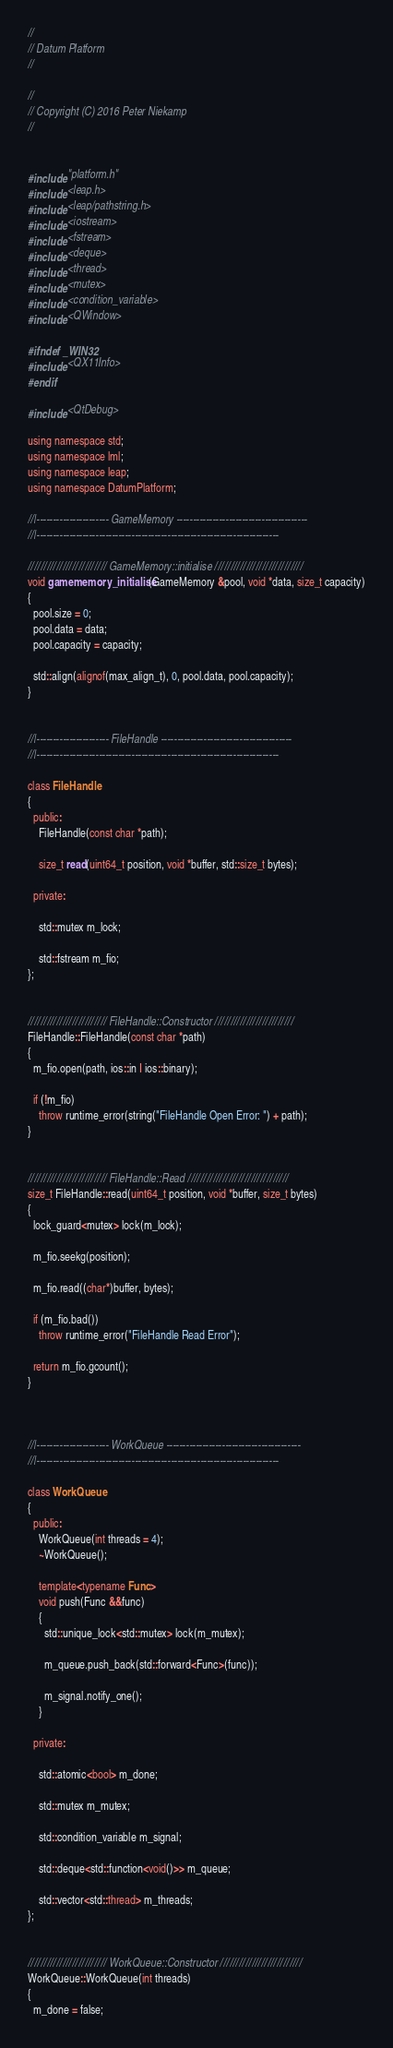<code> <loc_0><loc_0><loc_500><loc_500><_C++_>//
// Datum Platform
//

//
// Copyright (C) 2016 Peter Niekamp
//


#include "platform.h"
#include <leap.h>
#include <leap/pathstring.h>
#include <iostream>
#include <fstream>
#include <deque>
#include <thread>
#include <mutex>
#include <condition_variable>
#include <QWindow>

#ifndef _WIN32
#include <QX11Info>
#endif

#include <QtDebug>

using namespace std;
using namespace lml;
using namespace leap;
using namespace DatumPlatform;

//|---------------------- GameMemory ----------------------------------------
//|--------------------------------------------------------------------------

///////////////////////// GameMemory::initialise ////////////////////////////
void gamememory_initialise(GameMemory &pool, void *data, size_t capacity)
{
  pool.size = 0;
  pool.data = data;
  pool.capacity = capacity;

  std::align(alignof(max_align_t), 0, pool.data, pool.capacity);
}


//|---------------------- FileHandle ----------------------------------------
//|--------------------------------------------------------------------------

class FileHandle
{
  public:
    FileHandle(const char *path);

    size_t read(uint64_t position, void *buffer, std::size_t bytes);

  private:

    std::mutex m_lock;

    std::fstream m_fio;
};


///////////////////////// FileHandle::Constructor /////////////////////////
FileHandle::FileHandle(const char *path)
{
  m_fio.open(path, ios::in | ios::binary);

  if (!m_fio)
    throw runtime_error(string("FileHandle Open Error: ") + path);
}


///////////////////////// FileHandle::Read ////////////////////////////////
size_t FileHandle::read(uint64_t position, void *buffer, size_t bytes)
{
  lock_guard<mutex> lock(m_lock);

  m_fio.seekg(position);

  m_fio.read((char*)buffer, bytes);

  if (m_fio.bad())
    throw runtime_error("FileHandle Read Error");

  return m_fio.gcount();
}



//|---------------------- WorkQueue -----------------------------------------
//|--------------------------------------------------------------------------

class WorkQueue
{
  public:
    WorkQueue(int threads = 4);
    ~WorkQueue();

    template<typename Func>
    void push(Func &&func)
    {
      std::unique_lock<std::mutex> lock(m_mutex);

      m_queue.push_back(std::forward<Func>(func));

      m_signal.notify_one();
    }

  private:

    std::atomic<bool> m_done;

    std::mutex m_mutex;

    std::condition_variable m_signal;

    std::deque<std::function<void()>> m_queue;

    std::vector<std::thread> m_threads;
};


///////////////////////// WorkQueue::Constructor //////////////////////////
WorkQueue::WorkQueue(int threads)
{
  m_done = false;
</code> 